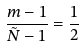Convert formula to latex. <formula><loc_0><loc_0><loc_500><loc_500>\frac { m - 1 } { \tilde { N } - 1 } = \frac { 1 } { 2 }</formula> 